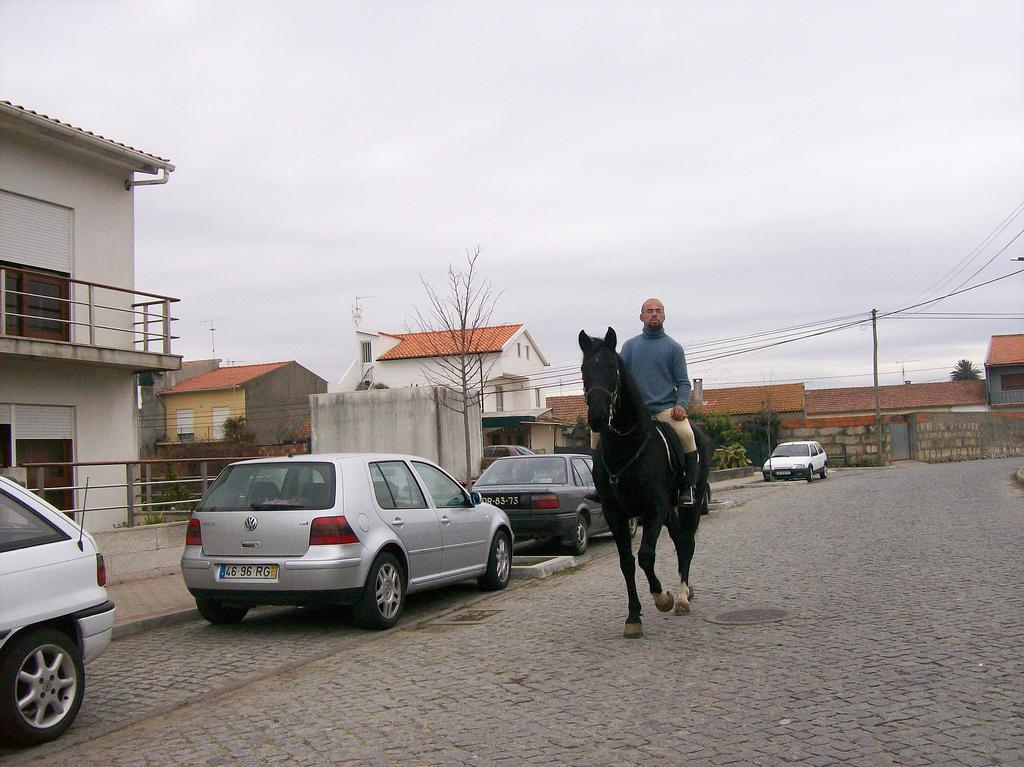Question: how many people are there?
Choices:
A. 2.
B. 3.
C. 4.
D. 1.
Answer with the letter. Answer: D Question: what kind of hairstyle does the person have?
Choices:
A. Stylish.
B. Suave.
C. Bold.
D. Extravagant.
Answer with the letter. Answer: C Question: how many cars are there?
Choices:
A. 10.
B. 5.
C. 4.
D. 3.
Answer with the letter. Answer: C Question: what is the color of the horse?
Choices:
A. Grey.
B. Black.
C. White.
D. Brown.
Answer with the letter. Answer: B Question: what is the man doing?
Choices:
A. Kicking the can.
B. Running away.
C. Riding a horse.
D. Laughing.
Answer with the letter. Answer: C Question: who is riding the horse?
Choices:
A. The champ.
B. A man.
C. A beginner.
D. An actor.
Answer with the letter. Answer: B Question: what color are the roofs?
Choices:
A. Red.
B. Orange.
C. Brown.
D. Blue.
Answer with the letter. Answer: B Question: how does the sky look?
Choices:
A. The sky is bright blue.
B. The sky has no clouds today.
C. The sky is filled with big white puffy clouds.
D. The sky is cloudy.
Answer with the letter. Answer: D Question: what color is the horse?
Choices:
A. The horse is brown.
B. Grey.
C. Black.
D. Red.
Answer with the letter. Answer: A Question: how many cars are on the street?
Choices:
A. One.
B. Five.
C. Twenty-one.
D. Four.
Answer with the letter. Answer: D Question: what is the horseback rider wearing?
Choices:
A. A Jacket.
B. Boots.
C. Jeans.
D. Gloves.
Answer with the letter. Answer: B Question: what doesn't have any leaves?
Choices:
A. A cactus.
B. A grass.
C. A tree.
D. Wheat grass.
Answer with the letter. Answer: C Question: what color are the horses hooves?
Choices:
A. Light colored.
B. Dark colored.
C. Black.
D. Gray.
Answer with the letter. Answer: A Question: what kind of sweater is the man wearing?
Choices:
A. Turtleneck.
B. Crew neck.
C. V-neck.
D. Cardigan.
Answer with the letter. Answer: A 